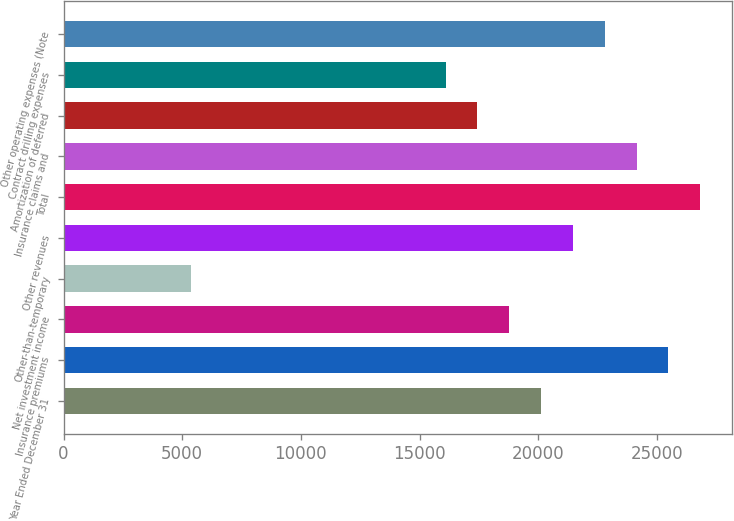Convert chart to OTSL. <chart><loc_0><loc_0><loc_500><loc_500><bar_chart><fcel>Year Ended December 31<fcel>Insurance premiums<fcel>Net investment income<fcel>Other-than-temporary<fcel>Other revenues<fcel>Total<fcel>Insurance claims and<fcel>Amortization of deferred<fcel>Contract drilling expenses<fcel>Other operating expenses (Note<nl><fcel>20122.2<fcel>25487.9<fcel>18780.7<fcel>5366.44<fcel>21463.6<fcel>26829.3<fcel>24146.5<fcel>17439.3<fcel>16097.9<fcel>22805<nl></chart> 